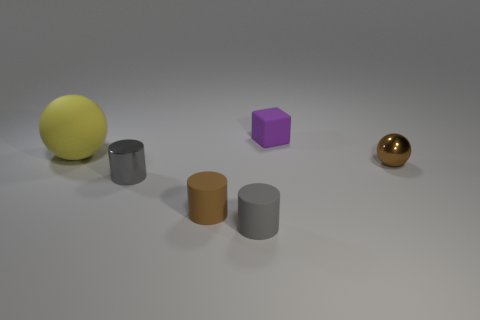How many cyan matte balls have the same size as the shiny cylinder?
Keep it short and to the point. 0. What material is the brown ball?
Keep it short and to the point. Metal. Is the number of small matte cylinders greater than the number of big cylinders?
Provide a short and direct response. Yes. Is the small gray shiny thing the same shape as the brown matte object?
Your response must be concise. Yes. Are there any other things that are the same shape as the purple matte thing?
Your response must be concise. No. There is a thing right of the tiny purple thing; is its color the same as the tiny rubber cylinder that is behind the tiny gray matte cylinder?
Provide a succinct answer. Yes. Is the number of tiny brown metallic spheres that are on the left side of the metallic ball less than the number of tiny brown metal spheres to the right of the yellow sphere?
Provide a short and direct response. Yes. There is a thing that is on the right side of the tiny matte cube; what is its shape?
Ensure brevity in your answer.  Sphere. How many other things are made of the same material as the small brown cylinder?
Your answer should be very brief. 3. There is a big yellow rubber thing; is it the same shape as the small metal object that is to the right of the brown cylinder?
Give a very brief answer. Yes. 